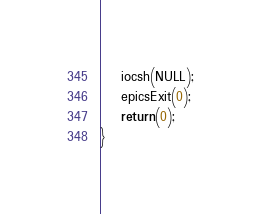Convert code to text. <code><loc_0><loc_0><loc_500><loc_500><_C++_>    iocsh(NULL);
    epicsExit(0);
    return(0);
}
</code> 